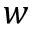<formula> <loc_0><loc_0><loc_500><loc_500>w</formula> 